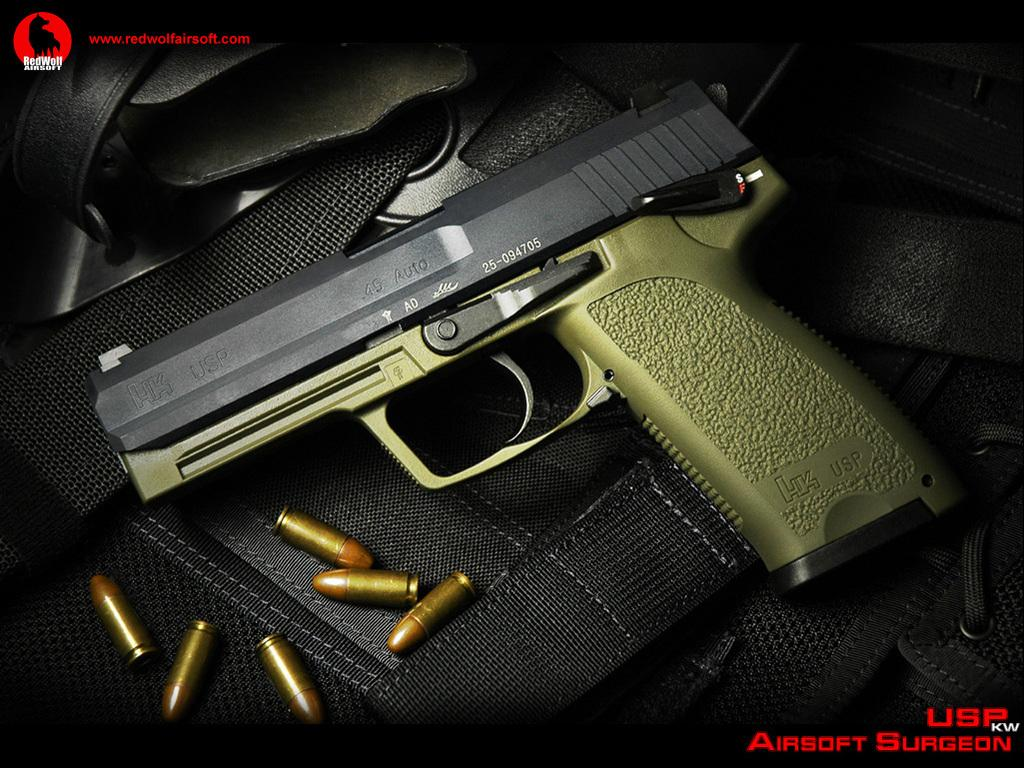What type of weapon is present in the image? There is a gun in the picture. What ammunition is associated with the gun in the image? There are bullets in the picture. What is the color of the surface where the gun and bullets are placed? The surface is black. How does the gun affect the person's nerves in the image? There is no person present in the image, so it is not possible to determine how the gun affects their nerves. 